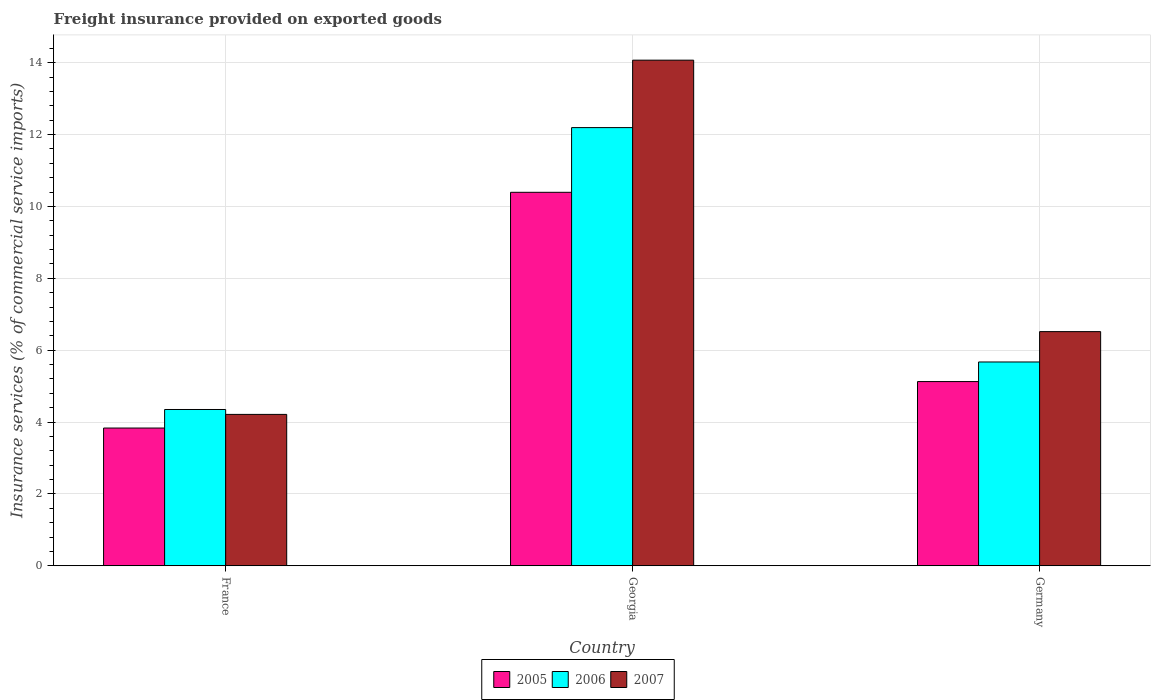How many different coloured bars are there?
Make the answer very short. 3. How many bars are there on the 1st tick from the right?
Make the answer very short. 3. What is the label of the 1st group of bars from the left?
Your response must be concise. France. What is the freight insurance provided on exported goods in 2005 in Georgia?
Keep it short and to the point. 10.39. Across all countries, what is the maximum freight insurance provided on exported goods in 2007?
Provide a short and direct response. 14.07. Across all countries, what is the minimum freight insurance provided on exported goods in 2007?
Offer a terse response. 4.21. In which country was the freight insurance provided on exported goods in 2007 maximum?
Ensure brevity in your answer.  Georgia. In which country was the freight insurance provided on exported goods in 2007 minimum?
Offer a very short reply. France. What is the total freight insurance provided on exported goods in 2007 in the graph?
Offer a very short reply. 24.8. What is the difference between the freight insurance provided on exported goods in 2005 in France and that in Germany?
Your response must be concise. -1.29. What is the difference between the freight insurance provided on exported goods in 2005 in Georgia and the freight insurance provided on exported goods in 2007 in France?
Your answer should be compact. 6.18. What is the average freight insurance provided on exported goods in 2005 per country?
Provide a short and direct response. 6.45. What is the difference between the freight insurance provided on exported goods of/in 2007 and freight insurance provided on exported goods of/in 2005 in France?
Provide a succinct answer. 0.38. What is the ratio of the freight insurance provided on exported goods in 2007 in Georgia to that in Germany?
Make the answer very short. 2.16. Is the difference between the freight insurance provided on exported goods in 2007 in France and Germany greater than the difference between the freight insurance provided on exported goods in 2005 in France and Germany?
Keep it short and to the point. No. What is the difference between the highest and the second highest freight insurance provided on exported goods in 2007?
Provide a succinct answer. -9.86. What is the difference between the highest and the lowest freight insurance provided on exported goods in 2007?
Offer a terse response. 9.86. In how many countries, is the freight insurance provided on exported goods in 2005 greater than the average freight insurance provided on exported goods in 2005 taken over all countries?
Provide a short and direct response. 1. What does the 1st bar from the left in Georgia represents?
Keep it short and to the point. 2005. Is it the case that in every country, the sum of the freight insurance provided on exported goods in 2006 and freight insurance provided on exported goods in 2005 is greater than the freight insurance provided on exported goods in 2007?
Keep it short and to the point. Yes. What is the difference between two consecutive major ticks on the Y-axis?
Make the answer very short. 2. Are the values on the major ticks of Y-axis written in scientific E-notation?
Give a very brief answer. No. Where does the legend appear in the graph?
Your answer should be very brief. Bottom center. How are the legend labels stacked?
Keep it short and to the point. Horizontal. What is the title of the graph?
Keep it short and to the point. Freight insurance provided on exported goods. Does "1976" appear as one of the legend labels in the graph?
Keep it short and to the point. No. What is the label or title of the Y-axis?
Keep it short and to the point. Insurance services (% of commercial service imports). What is the Insurance services (% of commercial service imports) of 2005 in France?
Provide a succinct answer. 3.83. What is the Insurance services (% of commercial service imports) in 2006 in France?
Your answer should be compact. 4.35. What is the Insurance services (% of commercial service imports) in 2007 in France?
Offer a very short reply. 4.21. What is the Insurance services (% of commercial service imports) in 2005 in Georgia?
Provide a succinct answer. 10.39. What is the Insurance services (% of commercial service imports) of 2006 in Georgia?
Offer a very short reply. 12.19. What is the Insurance services (% of commercial service imports) of 2007 in Georgia?
Offer a very short reply. 14.07. What is the Insurance services (% of commercial service imports) of 2005 in Germany?
Your answer should be very brief. 5.13. What is the Insurance services (% of commercial service imports) in 2006 in Germany?
Provide a short and direct response. 5.67. What is the Insurance services (% of commercial service imports) in 2007 in Germany?
Your response must be concise. 6.52. Across all countries, what is the maximum Insurance services (% of commercial service imports) in 2005?
Your answer should be compact. 10.39. Across all countries, what is the maximum Insurance services (% of commercial service imports) of 2006?
Ensure brevity in your answer.  12.19. Across all countries, what is the maximum Insurance services (% of commercial service imports) in 2007?
Provide a succinct answer. 14.07. Across all countries, what is the minimum Insurance services (% of commercial service imports) of 2005?
Provide a succinct answer. 3.83. Across all countries, what is the minimum Insurance services (% of commercial service imports) in 2006?
Offer a terse response. 4.35. Across all countries, what is the minimum Insurance services (% of commercial service imports) in 2007?
Your answer should be compact. 4.21. What is the total Insurance services (% of commercial service imports) of 2005 in the graph?
Keep it short and to the point. 19.35. What is the total Insurance services (% of commercial service imports) in 2006 in the graph?
Keep it short and to the point. 22.21. What is the total Insurance services (% of commercial service imports) in 2007 in the graph?
Make the answer very short. 24.8. What is the difference between the Insurance services (% of commercial service imports) in 2005 in France and that in Georgia?
Your response must be concise. -6.56. What is the difference between the Insurance services (% of commercial service imports) in 2006 in France and that in Georgia?
Your answer should be compact. -7.84. What is the difference between the Insurance services (% of commercial service imports) of 2007 in France and that in Georgia?
Offer a terse response. -9.86. What is the difference between the Insurance services (% of commercial service imports) of 2005 in France and that in Germany?
Provide a succinct answer. -1.29. What is the difference between the Insurance services (% of commercial service imports) in 2006 in France and that in Germany?
Provide a short and direct response. -1.32. What is the difference between the Insurance services (% of commercial service imports) of 2007 in France and that in Germany?
Your answer should be very brief. -2.3. What is the difference between the Insurance services (% of commercial service imports) of 2005 in Georgia and that in Germany?
Give a very brief answer. 5.27. What is the difference between the Insurance services (% of commercial service imports) in 2006 in Georgia and that in Germany?
Offer a very short reply. 6.52. What is the difference between the Insurance services (% of commercial service imports) of 2007 in Georgia and that in Germany?
Keep it short and to the point. 7.55. What is the difference between the Insurance services (% of commercial service imports) of 2005 in France and the Insurance services (% of commercial service imports) of 2006 in Georgia?
Your response must be concise. -8.36. What is the difference between the Insurance services (% of commercial service imports) in 2005 in France and the Insurance services (% of commercial service imports) in 2007 in Georgia?
Provide a succinct answer. -10.24. What is the difference between the Insurance services (% of commercial service imports) in 2006 in France and the Insurance services (% of commercial service imports) in 2007 in Georgia?
Provide a succinct answer. -9.72. What is the difference between the Insurance services (% of commercial service imports) in 2005 in France and the Insurance services (% of commercial service imports) in 2006 in Germany?
Your answer should be compact. -1.84. What is the difference between the Insurance services (% of commercial service imports) in 2005 in France and the Insurance services (% of commercial service imports) in 2007 in Germany?
Offer a terse response. -2.68. What is the difference between the Insurance services (% of commercial service imports) of 2006 in France and the Insurance services (% of commercial service imports) of 2007 in Germany?
Give a very brief answer. -2.17. What is the difference between the Insurance services (% of commercial service imports) of 2005 in Georgia and the Insurance services (% of commercial service imports) of 2006 in Germany?
Your response must be concise. 4.72. What is the difference between the Insurance services (% of commercial service imports) of 2005 in Georgia and the Insurance services (% of commercial service imports) of 2007 in Germany?
Give a very brief answer. 3.88. What is the difference between the Insurance services (% of commercial service imports) of 2006 in Georgia and the Insurance services (% of commercial service imports) of 2007 in Germany?
Your response must be concise. 5.68. What is the average Insurance services (% of commercial service imports) of 2005 per country?
Your answer should be very brief. 6.45. What is the average Insurance services (% of commercial service imports) of 2006 per country?
Your response must be concise. 7.4. What is the average Insurance services (% of commercial service imports) of 2007 per country?
Keep it short and to the point. 8.27. What is the difference between the Insurance services (% of commercial service imports) in 2005 and Insurance services (% of commercial service imports) in 2006 in France?
Provide a short and direct response. -0.52. What is the difference between the Insurance services (% of commercial service imports) in 2005 and Insurance services (% of commercial service imports) in 2007 in France?
Make the answer very short. -0.38. What is the difference between the Insurance services (% of commercial service imports) in 2006 and Insurance services (% of commercial service imports) in 2007 in France?
Make the answer very short. 0.14. What is the difference between the Insurance services (% of commercial service imports) of 2005 and Insurance services (% of commercial service imports) of 2006 in Georgia?
Offer a terse response. -1.8. What is the difference between the Insurance services (% of commercial service imports) of 2005 and Insurance services (% of commercial service imports) of 2007 in Georgia?
Provide a succinct answer. -3.68. What is the difference between the Insurance services (% of commercial service imports) in 2006 and Insurance services (% of commercial service imports) in 2007 in Georgia?
Provide a short and direct response. -1.88. What is the difference between the Insurance services (% of commercial service imports) in 2005 and Insurance services (% of commercial service imports) in 2006 in Germany?
Offer a very short reply. -0.55. What is the difference between the Insurance services (% of commercial service imports) in 2005 and Insurance services (% of commercial service imports) in 2007 in Germany?
Your answer should be compact. -1.39. What is the difference between the Insurance services (% of commercial service imports) of 2006 and Insurance services (% of commercial service imports) of 2007 in Germany?
Your answer should be compact. -0.84. What is the ratio of the Insurance services (% of commercial service imports) of 2005 in France to that in Georgia?
Give a very brief answer. 0.37. What is the ratio of the Insurance services (% of commercial service imports) in 2006 in France to that in Georgia?
Provide a succinct answer. 0.36. What is the ratio of the Insurance services (% of commercial service imports) of 2007 in France to that in Georgia?
Provide a short and direct response. 0.3. What is the ratio of the Insurance services (% of commercial service imports) in 2005 in France to that in Germany?
Offer a terse response. 0.75. What is the ratio of the Insurance services (% of commercial service imports) of 2006 in France to that in Germany?
Give a very brief answer. 0.77. What is the ratio of the Insurance services (% of commercial service imports) in 2007 in France to that in Germany?
Offer a very short reply. 0.65. What is the ratio of the Insurance services (% of commercial service imports) of 2005 in Georgia to that in Germany?
Offer a very short reply. 2.03. What is the ratio of the Insurance services (% of commercial service imports) of 2006 in Georgia to that in Germany?
Your answer should be compact. 2.15. What is the ratio of the Insurance services (% of commercial service imports) in 2007 in Georgia to that in Germany?
Your answer should be compact. 2.16. What is the difference between the highest and the second highest Insurance services (% of commercial service imports) in 2005?
Provide a succinct answer. 5.27. What is the difference between the highest and the second highest Insurance services (% of commercial service imports) in 2006?
Your response must be concise. 6.52. What is the difference between the highest and the second highest Insurance services (% of commercial service imports) in 2007?
Give a very brief answer. 7.55. What is the difference between the highest and the lowest Insurance services (% of commercial service imports) in 2005?
Keep it short and to the point. 6.56. What is the difference between the highest and the lowest Insurance services (% of commercial service imports) in 2006?
Give a very brief answer. 7.84. What is the difference between the highest and the lowest Insurance services (% of commercial service imports) in 2007?
Offer a very short reply. 9.86. 